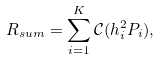<formula> <loc_0><loc_0><loc_500><loc_500>R _ { s u m } = \sum _ { i = 1 } ^ { K } \mathcal { C } ( h _ { i } ^ { 2 } P _ { i } ) ,</formula> 